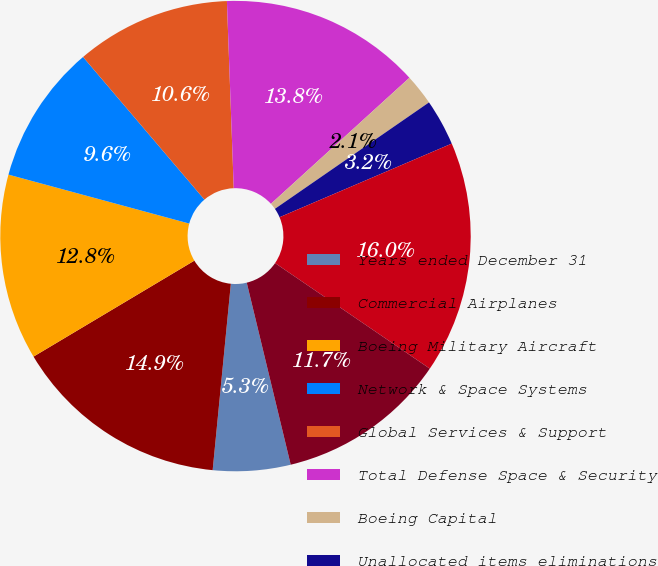<chart> <loc_0><loc_0><loc_500><loc_500><pie_chart><fcel>Years ended December 31<fcel>Commercial Airplanes<fcel>Boeing Military Aircraft<fcel>Network & Space Systems<fcel>Global Services & Support<fcel>Total Defense Space & Security<fcel>Boeing Capital<fcel>Unallocated items eliminations<fcel>Total revenues<fcel>Segment operating profit<nl><fcel>5.32%<fcel>14.89%<fcel>12.77%<fcel>9.57%<fcel>10.64%<fcel>13.83%<fcel>2.13%<fcel>3.19%<fcel>15.96%<fcel>11.7%<nl></chart> 